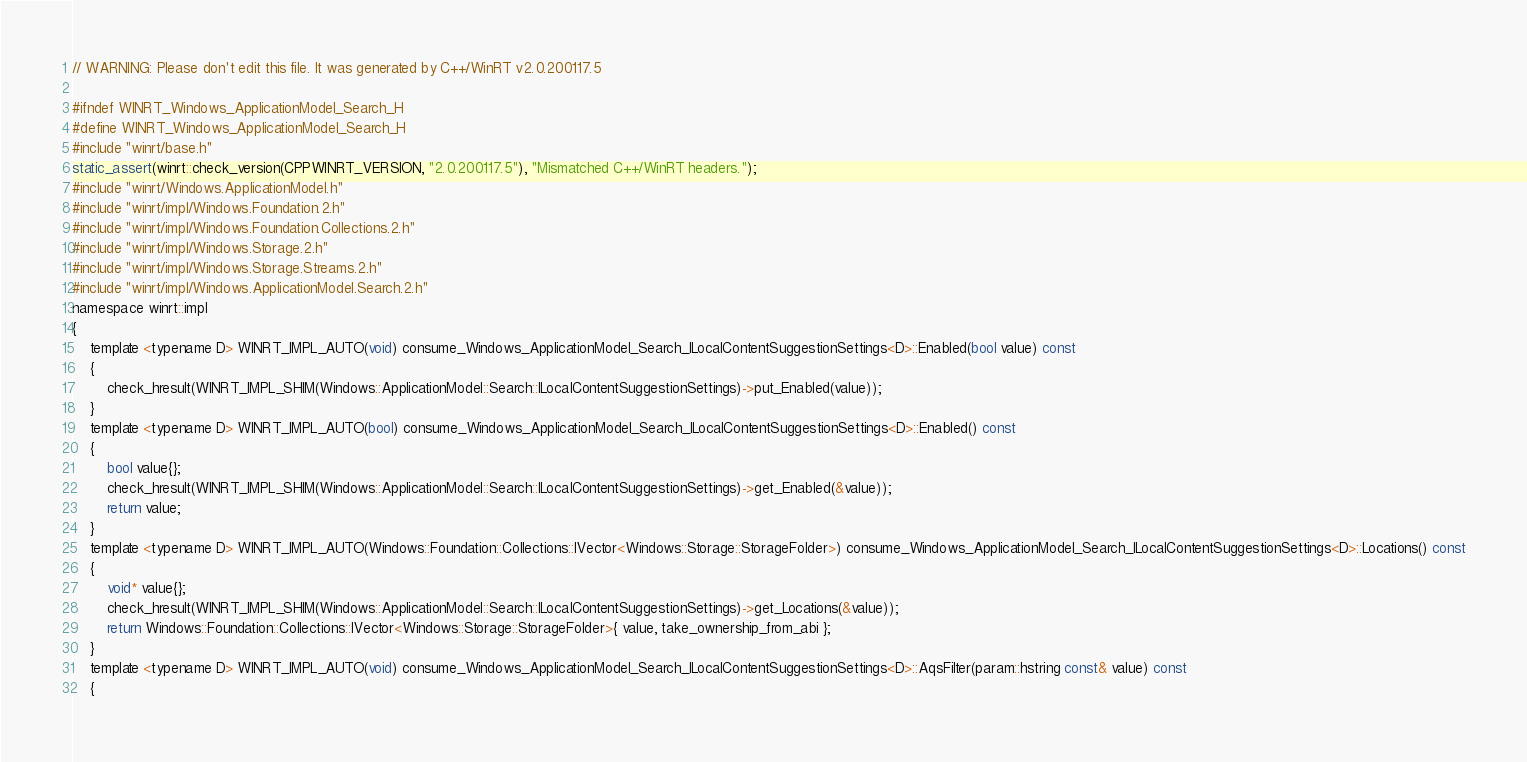<code> <loc_0><loc_0><loc_500><loc_500><_C_>// WARNING: Please don't edit this file. It was generated by C++/WinRT v2.0.200117.5

#ifndef WINRT_Windows_ApplicationModel_Search_H
#define WINRT_Windows_ApplicationModel_Search_H
#include "winrt/base.h"
static_assert(winrt::check_version(CPPWINRT_VERSION, "2.0.200117.5"), "Mismatched C++/WinRT headers.");
#include "winrt/Windows.ApplicationModel.h"
#include "winrt/impl/Windows.Foundation.2.h"
#include "winrt/impl/Windows.Foundation.Collections.2.h"
#include "winrt/impl/Windows.Storage.2.h"
#include "winrt/impl/Windows.Storage.Streams.2.h"
#include "winrt/impl/Windows.ApplicationModel.Search.2.h"
namespace winrt::impl
{
    template <typename D> WINRT_IMPL_AUTO(void) consume_Windows_ApplicationModel_Search_ILocalContentSuggestionSettings<D>::Enabled(bool value) const
    {
        check_hresult(WINRT_IMPL_SHIM(Windows::ApplicationModel::Search::ILocalContentSuggestionSettings)->put_Enabled(value));
    }
    template <typename D> WINRT_IMPL_AUTO(bool) consume_Windows_ApplicationModel_Search_ILocalContentSuggestionSettings<D>::Enabled() const
    {
        bool value{};
        check_hresult(WINRT_IMPL_SHIM(Windows::ApplicationModel::Search::ILocalContentSuggestionSettings)->get_Enabled(&value));
        return value;
    }
    template <typename D> WINRT_IMPL_AUTO(Windows::Foundation::Collections::IVector<Windows::Storage::StorageFolder>) consume_Windows_ApplicationModel_Search_ILocalContentSuggestionSettings<D>::Locations() const
    {
        void* value{};
        check_hresult(WINRT_IMPL_SHIM(Windows::ApplicationModel::Search::ILocalContentSuggestionSettings)->get_Locations(&value));
        return Windows::Foundation::Collections::IVector<Windows::Storage::StorageFolder>{ value, take_ownership_from_abi };
    }
    template <typename D> WINRT_IMPL_AUTO(void) consume_Windows_ApplicationModel_Search_ILocalContentSuggestionSettings<D>::AqsFilter(param::hstring const& value) const
    {</code> 